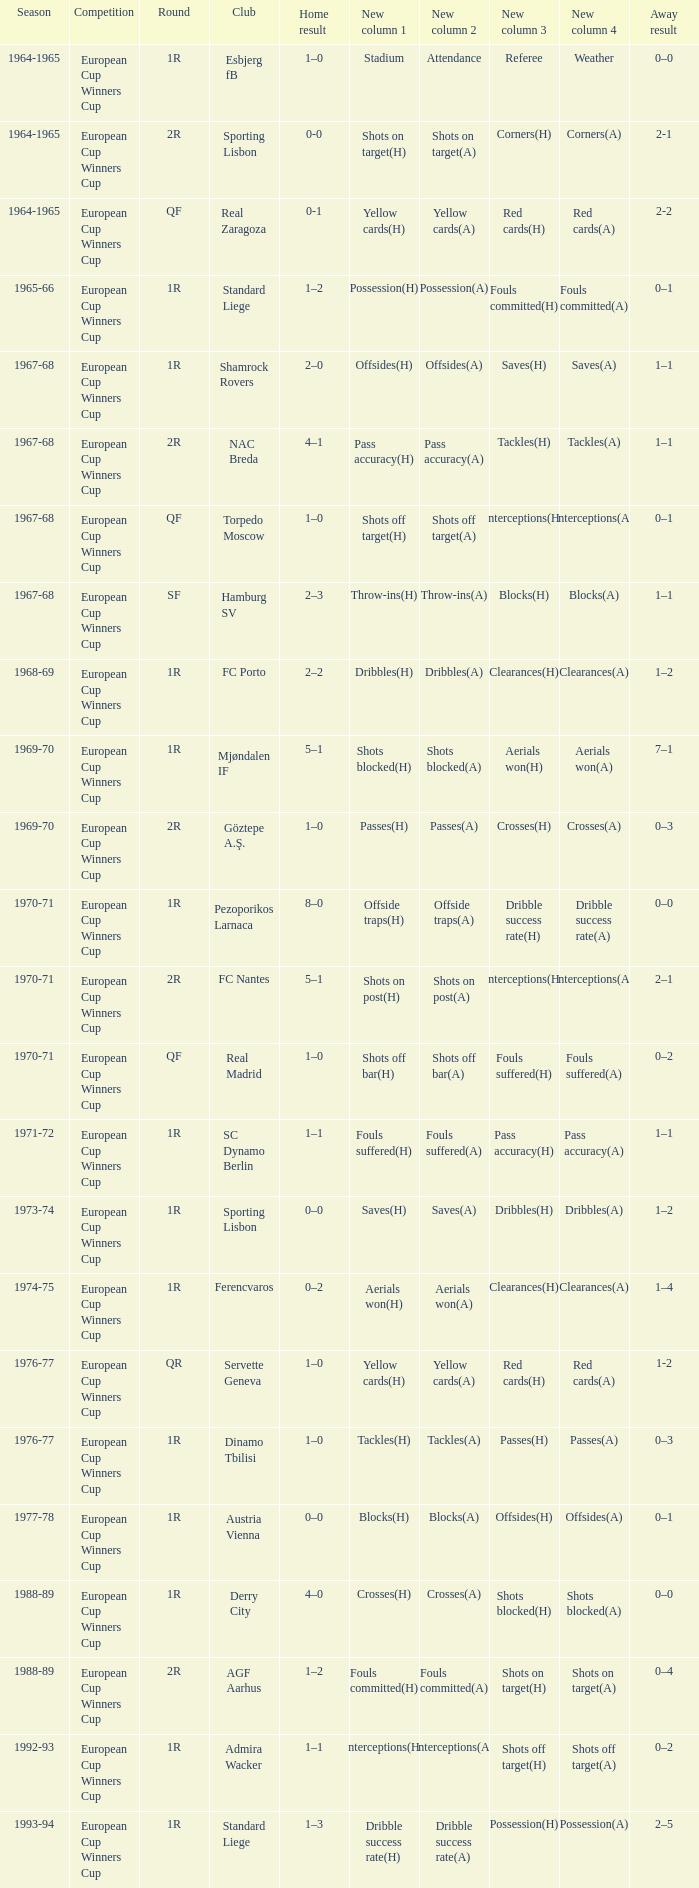Away result of 1-2 has what season? 1976-77. 